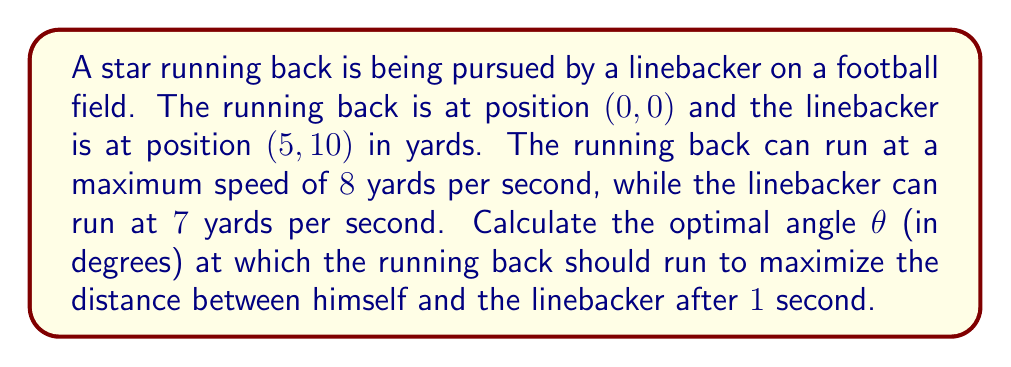Help me with this question. Let's approach this step-by-step:

1) First, we need to set up the positions after 1 second:
   Running back: $(8\cos\theta, 8\sin\theta)$
   Linebacker: $(5, 10)$ (assuming he doesn't move in this short time)

2) The distance between them after 1 second is given by:
   $$d = \sqrt{(5-8\cos\theta)^2 + (10-8\sin\theta)^2}$$

3) To maximize this distance, we need to find the value of θ where the derivative of d with respect to θ is zero:
   $$\frac{d}{d\theta}d = \frac{d}{d\theta}\sqrt{(5-8\cos\theta)^2 + (10-8\sin\theta)^2} = 0$$

4) Applying the chain rule:
   $$\frac{(5-8\cos\theta)(8\sin\theta) + (10-8\sin\theta)(-8\cos\theta)}{\sqrt{(5-8\cos\theta)^2 + (10-8\sin\theta)^2}} = 0$$

5) Simplifying:
   $$(5-8\cos\theta)(8\sin\theta) + (10-8\sin\theta)(-8\cos\theta) = 0$$
   $$40\sin\theta - 64\sin\theta\cos\theta - 80\cos\theta + 64\sin\theta\cos\theta = 0$$
   $$40\sin\theta - 80\cos\theta = 0$$

6) Dividing both sides by 40:
   $$\sin\theta - 2\cos\theta = 0$$

7) This can be solved using the tangent half-angle formula:
   $$\tan\frac{\theta}{2} = \frac{1}{2-\sqrt{5}}$$

8) Taking the inverse tangent and multiplying by 2:
   $$\theta = 2\arctan(\frac{1}{2-\sqrt{5}})$$

9) Converting to degrees:
   $$\theta \approx 63.4349^\circ$$
Answer: $63.4^\circ$ 